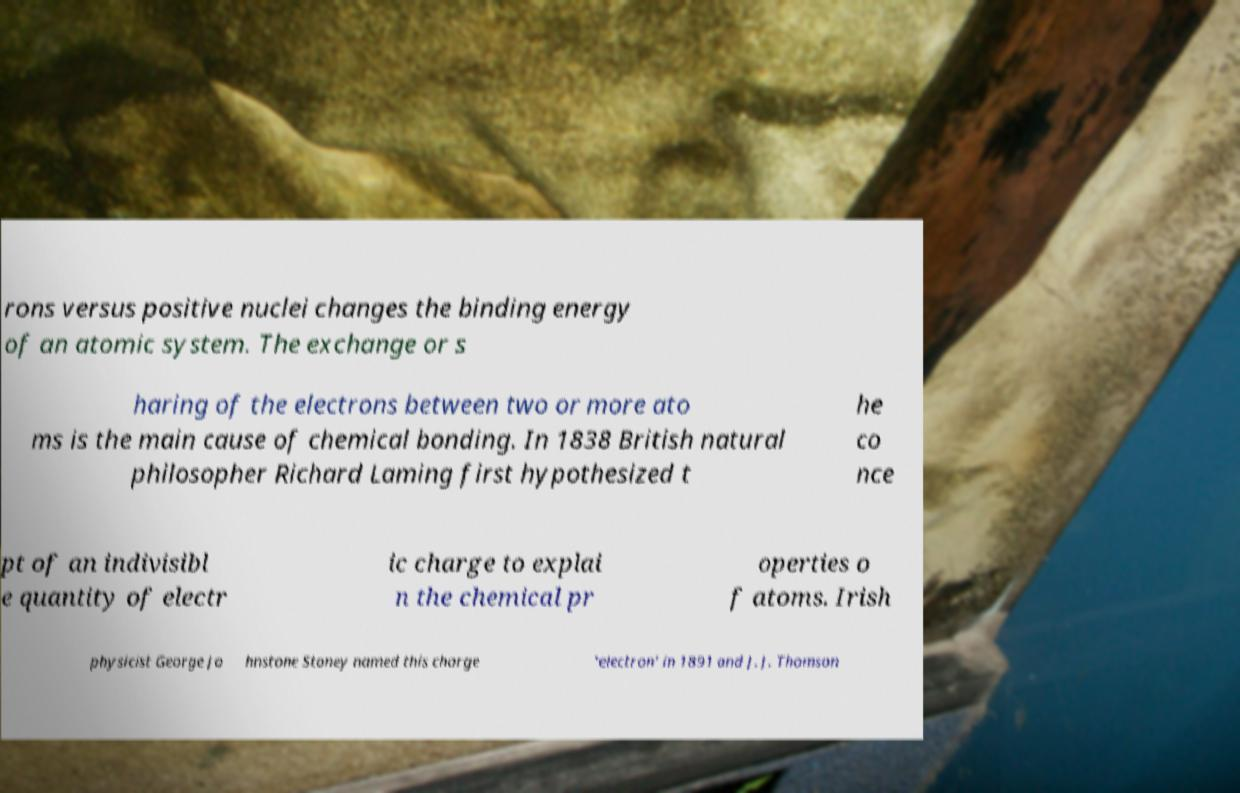Please read and relay the text visible in this image. What does it say? rons versus positive nuclei changes the binding energy of an atomic system. The exchange or s haring of the electrons between two or more ato ms is the main cause of chemical bonding. In 1838 British natural philosopher Richard Laming first hypothesized t he co nce pt of an indivisibl e quantity of electr ic charge to explai n the chemical pr operties o f atoms. Irish physicist George Jo hnstone Stoney named this charge 'electron' in 1891 and J. J. Thomson 